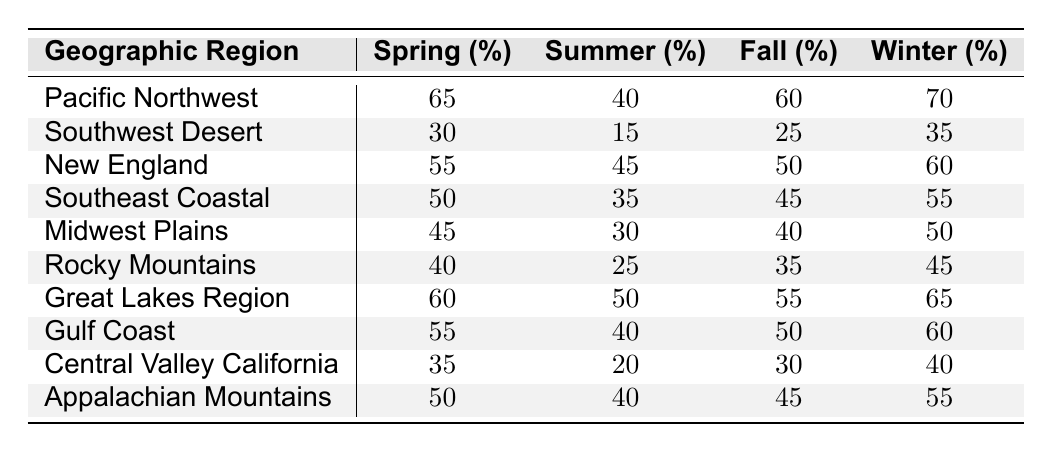What is the moisture retention percentage for the Pacific Northwest in spring? The Pacific Northwest's spring moisture retention is listed directly in the table as 65%.
Answer: 65% Which geographic region has the highest moisture retention in winter? In the winter column, the Pacific Northwest has the highest moisture retention at 70%.
Answer: Pacific Northwest What is the difference in moisture retention between summer and fall for the Southwest Desert? The summer retention for Southwest Desert is 15% and fall is 25%, so the difference is 25% - 15% = 10%.
Answer: 10% What is the average moisture retention in the summer across all listed regions? Adding the summer retention values: (40 + 15 + 45 + 35 + 30 + 25 + 50 + 40 + 20 + 40) = 390. There are 10 regions, so the average is 390 / 10 = 39%.
Answer: 39% Is the winter moisture retention for the Great Lakes Region greater than that of the Appalachain Mountains? The Great Lakes Region has 65% in winter, while the Appalachian Mountains have 55%; 65% > 55% indicates that the Great Lakes Region has greater winter moisture retention.
Answer: Yes In which season does the Southeast Coastal region show the least moisture retention? Checking the percentage values for Southeast Coastal: Spring 50%, Summer 35%, Fall 45%, Winter 55%. The lowest is 35% in summer.
Answer: Summer Calculate the total moisture retention in fall for all regions combined. The fall moisture retention values are (60 + 25 + 50 + 45 + 40 + 35 + 55 + 50 + 30 + 45) = 435.
Answer: 435 Which region has the most consistent moisture retention across the seasons? Reviewing each region's values, the Southwest Desert shows the lowest values across all seasons, but the Great Lakes Region has the least variation between its values (60, 50, 55, 65). Therefore, it exhibits the most consistent retention.
Answer: Great Lakes Region How does the moisture retention in spring for the Midwest Plains compare to the Gulf Coast? The Midwest Plains shows 45% retention in spring compared to 55% for the Gulf Coast, indicating that Gulf Coast has higher spring moisture retention than Midwest Plains.
Answer: Gulf Coast is higher What season has the highest average moisture retention overall across all regions? Calculate the average for each season: Spring (65 + 30 + 55 + 50 + 45 + 40 + 60 + 55 + 35 + 50) / 10 = 50.5; Summer (40 + 15 + 45 + 35 + 30 + 25 + 50 + 40 + 20 + 40) / 10 = 39; Fall (60 + 25 + 50 + 45 + 40 + 35 + 55 + 50 + 30 + 45) / 10 = 43; Winter (70 + 35 + 60 + 55 + 50 + 45 + 65 + 60 + 40 + 55) / 10 = 53. The highest average is in winter at 53%.
Answer: Winter 